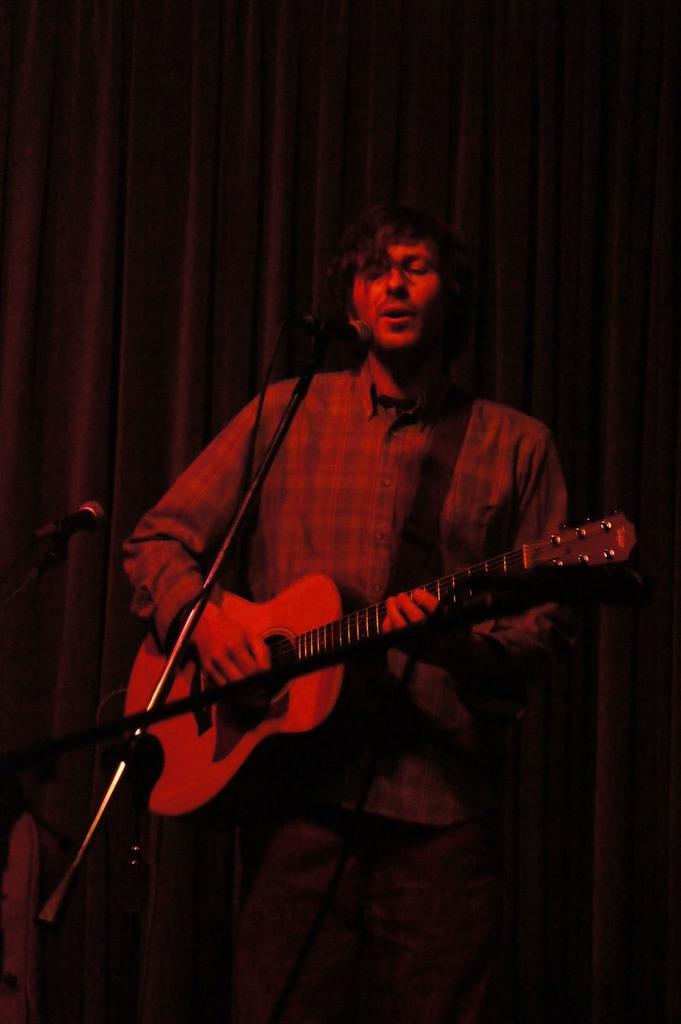What is the man in the image doing? The man is playing the guitar and singing on a microphone. What object is the man holding in the image? The man is holding a guitar. What can be seen in the background of the image? There is a curtain in the background of the image. What type of honey is the man using to play the guitar in the image? There is no honey present in the image, and the man is playing the guitar using his hands, not honey. Can you see any cattle in the image? No, there are no cattle present in the image. 